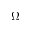<formula> <loc_0><loc_0><loc_500><loc_500>\Omega</formula> 